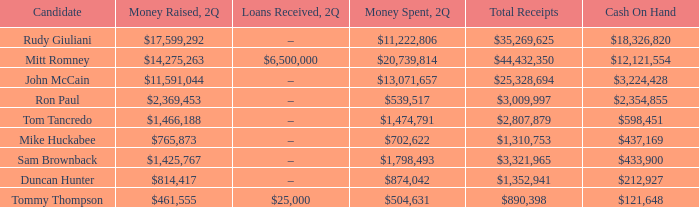Name the money spent for 2Q having candidate of john mccain $13,071,657. 